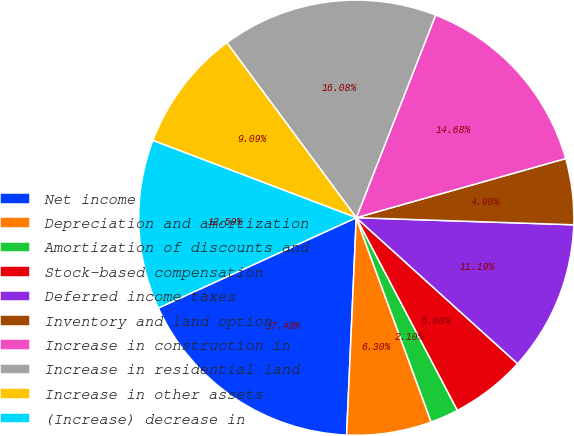Convert chart. <chart><loc_0><loc_0><loc_500><loc_500><pie_chart><fcel>Net income<fcel>Depreciation and amortization<fcel>Amortization of discounts and<fcel>Stock-based compensation<fcel>Deferred income taxes<fcel>Inventory and land option<fcel>Increase in construction in<fcel>Increase in residential land<fcel>Increase in other assets<fcel>(Increase) decrease in<nl><fcel>17.48%<fcel>6.3%<fcel>2.1%<fcel>5.6%<fcel>11.19%<fcel>4.9%<fcel>14.68%<fcel>16.08%<fcel>9.09%<fcel>12.59%<nl></chart> 